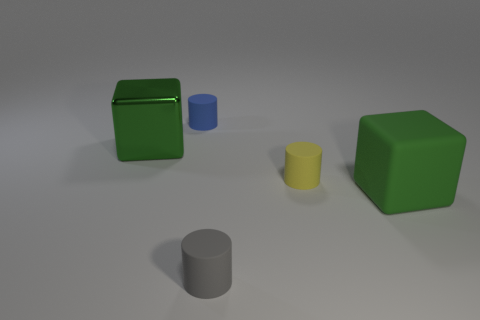How many cylinders are green things or blue rubber things?
Your response must be concise. 1. There is a small cylinder that is in front of the big object that is to the right of the green shiny block on the left side of the tiny blue object; what is its material?
Offer a very short reply. Rubber. What number of other objects are there of the same size as the metal block?
Your response must be concise. 1. The cube that is the same color as the shiny object is what size?
Make the answer very short. Large. Are there more yellow things that are in front of the matte block than green matte objects?
Your answer should be very brief. No. Are there any cylinders that have the same color as the metallic thing?
Make the answer very short. No. There is a matte object that is the same size as the green metallic thing; what color is it?
Offer a very short reply. Green. There is a green matte block that is right of the yellow matte object; what number of tiny blue matte cylinders are behind it?
Make the answer very short. 1. What number of things are either rubber objects that are behind the tiny gray rubber object or tiny green objects?
Your answer should be very brief. 3. How many large red balls are made of the same material as the tiny gray thing?
Offer a terse response. 0. 